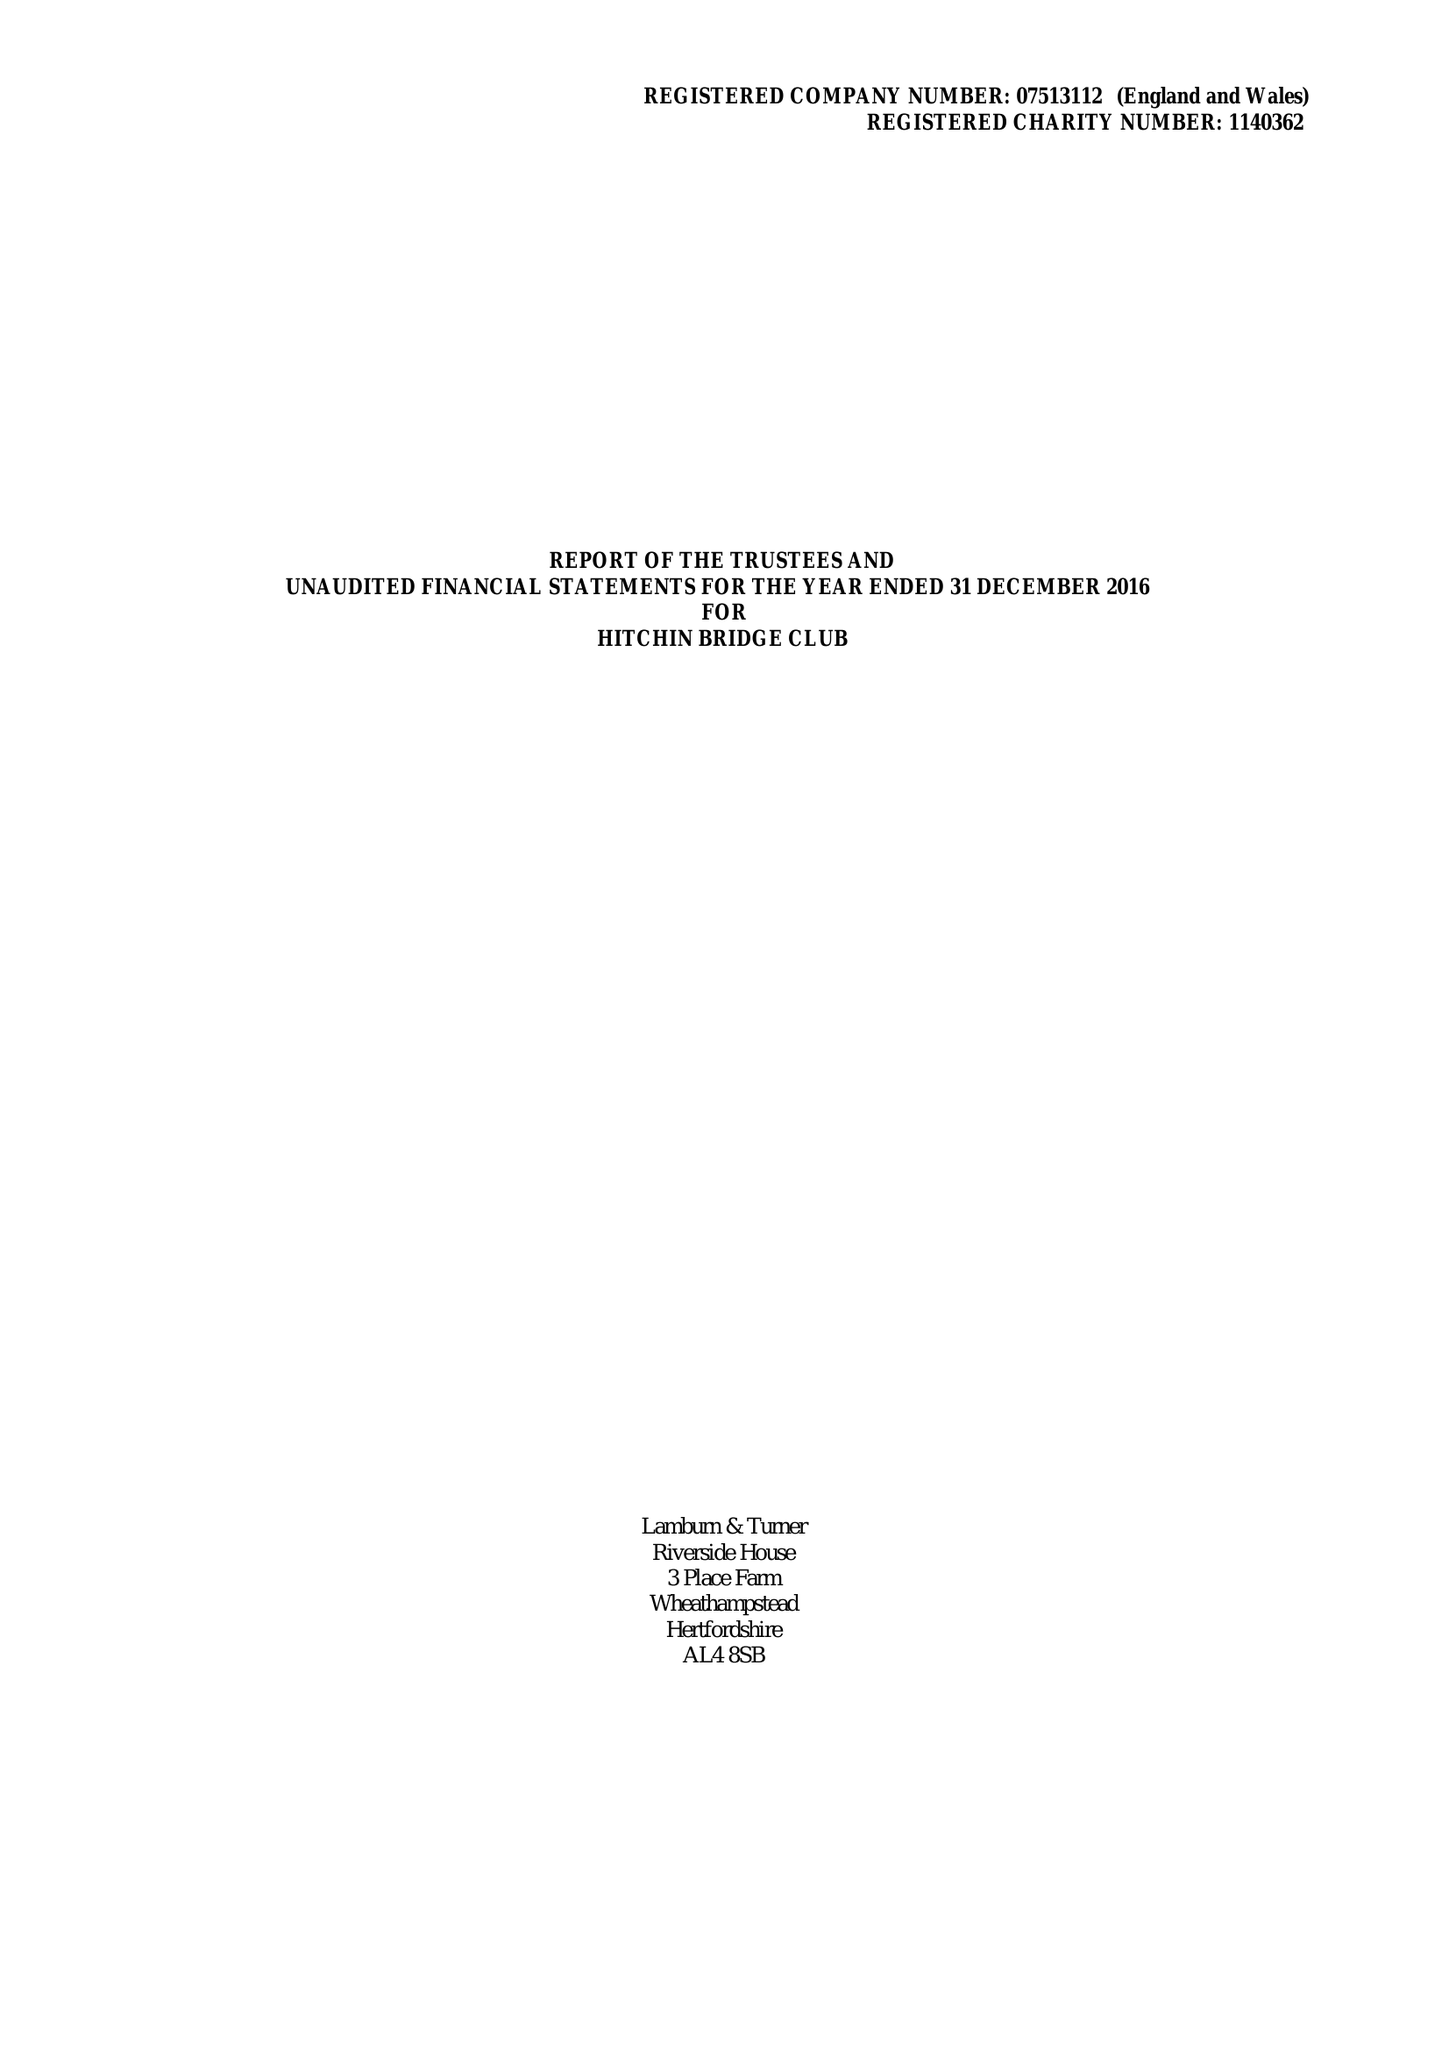What is the value for the spending_annually_in_british_pounds?
Answer the question using a single word or phrase. 17123.00 